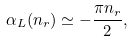<formula> <loc_0><loc_0><loc_500><loc_500>\alpha _ { L } ( n _ { r } ) \simeq - \frac { \pi n _ { r } } { 2 } ,</formula> 